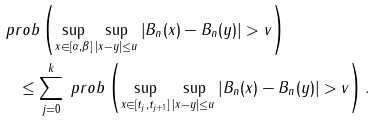<formula> <loc_0><loc_0><loc_500><loc_500>& \ p r o b \left ( \sup _ { x \in [ \alpha , \beta ] } \sup _ { | x - y | \leq u } \left | B _ { n } ( x ) - B _ { n } ( y ) \right | > v \right ) \\ & \quad \leq \sum _ { j = 0 } ^ { k } \ p r o b \left ( \sup _ { x \in [ t _ { j } , t _ { j + 1 } ] } \sup _ { | x - y | \leq u } \left | B _ { n } ( x ) - B _ { n } ( y ) \right | > v \right ) .</formula> 